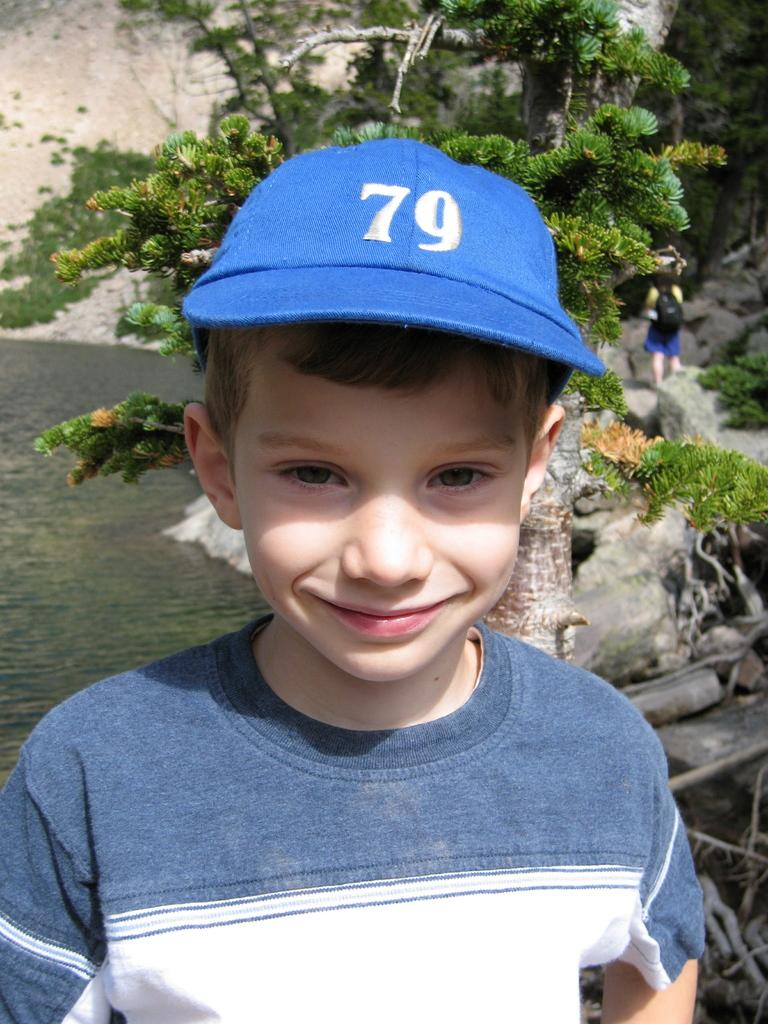How many people are in the image? There are people in the image, but the exact number is not specified. What is the boy doing in the image? The boy is smiling in the image. What is the boy wearing on his head? The boy is wearing a cap in the image. What can be seen in the background of the picture? There are trees and water visible in the background of the image. What type of toothbrush is the boy using in the image? There is no toothbrush present in the image. What arithmetic problem is the boy solving in the image? There is no arithmetic problem visible in the image. 